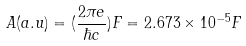<formula> <loc_0><loc_0><loc_500><loc_500>A ( a . u ) = ( \frac { 2 \pi e } { \hbar { c } } ) F = 2 . 6 7 3 \times 1 0 ^ { - 5 } F</formula> 